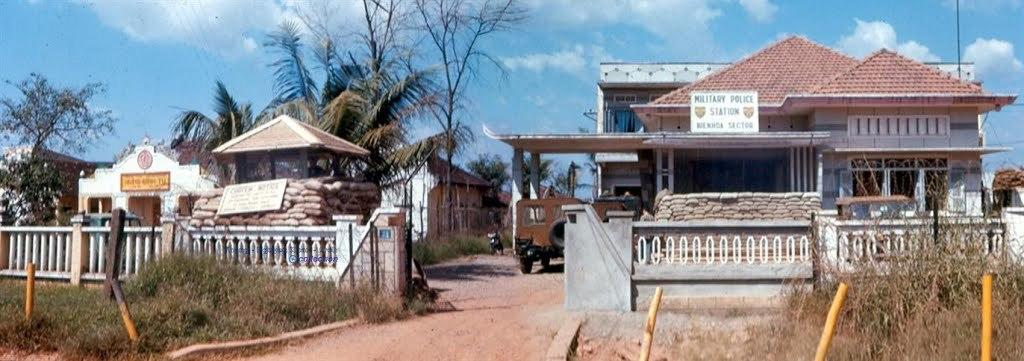What type of structures can be seen in the image? There are houses in the image. What other natural or man-made elements can be seen in the image? There are trees, vehicles, a fencing wall, plants, and poles in the image. Can you see a person walking across the bridge in the image? There is no bridge present in the image, and therefore no person walking across it. 